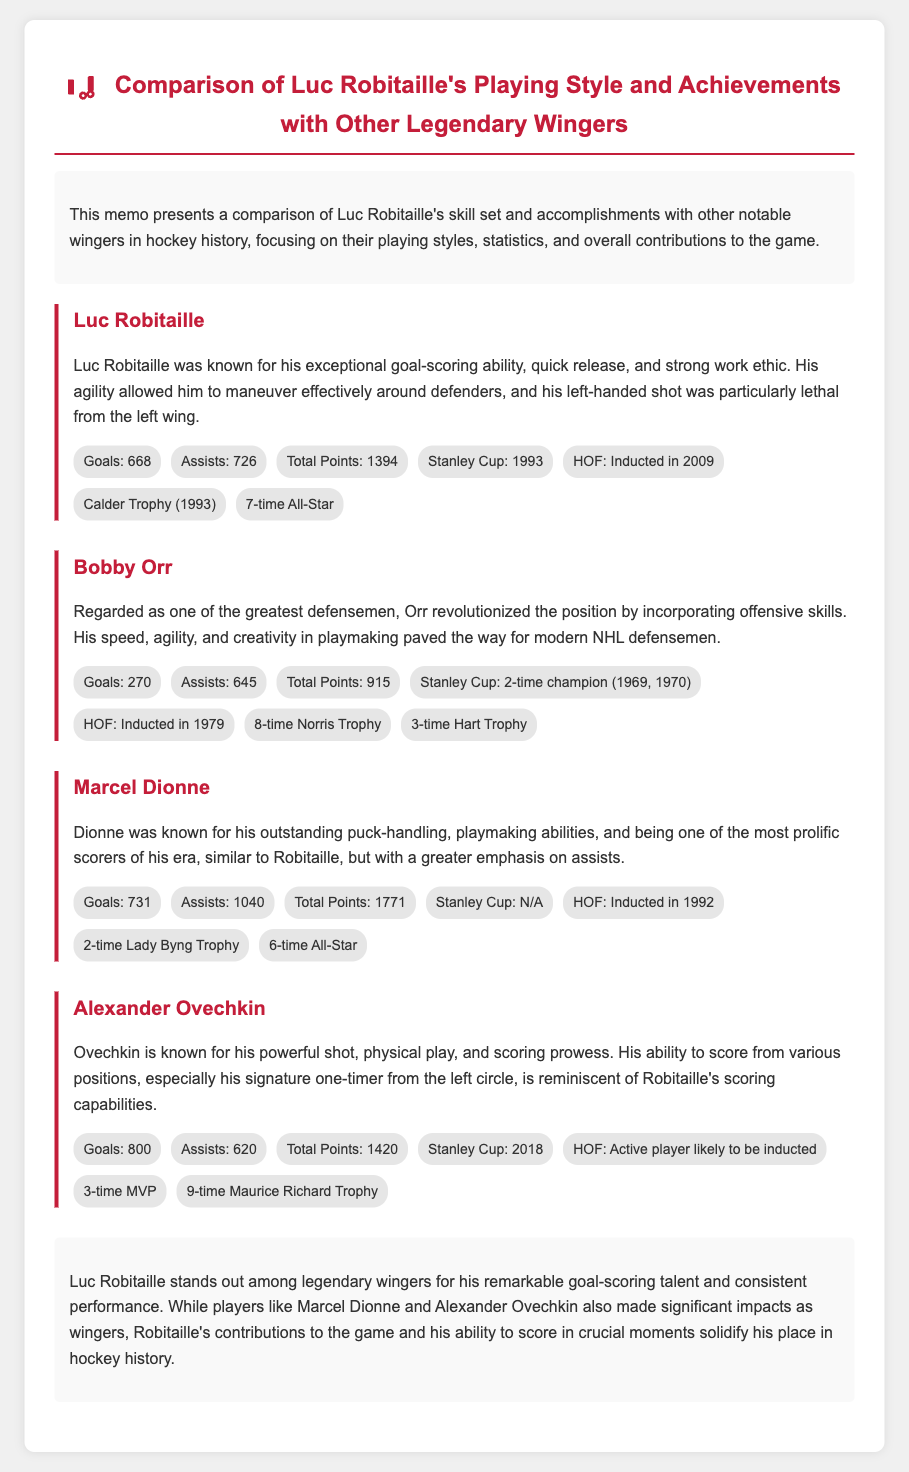What year was Luc Robitaille inducted into the Hall of Fame? The memo states that Luc Robitaille was inducted into the Hall of Fame in 2009.
Answer: 2009 How many goals did Marcel Dionne score? The document provides that Marcel Dionne scored a total of 731 goals during his career.
Answer: 731 What is Alexander Ovechkin's unique scoring trait mentioned in the memo? The memo mentions Ovechkin's ability to score especially with his signature one-timer from the left circle.
Answer: One-timer from the left circle Which trophy did Luc Robitaille win in 1993? The memo indicates that Robitaille won the Calder Trophy in 1993.
Answer: Calder Trophy Who has the highest total points in the document? The memo shows that Marcel Dionne has the highest total points with 1771.
Answer: 1771 What aspect of Luc Robitaille's playing style is highlighted in the memo? The document highlights Robitaille's exceptional goal-scoring ability and quick release as key aspects of his playing style.
Answer: Goal-scoring ability Who is mentioned as a 3-time Hart Trophy winner? The memo states that Bobby Orr won the Hart Trophy three times.
Answer: Bobby Orr What Major achievement did Alexander Ovechkin accomplish in 2018? The memo notes that Ovechkin won the Stanley Cup in 2018.
Answer: Stanley Cup Which player is associated with outstanding puck-handling according to the document? The memo attributes outstanding puck-handling abilities to Marcel Dionne.
Answer: Marcel Dionne 